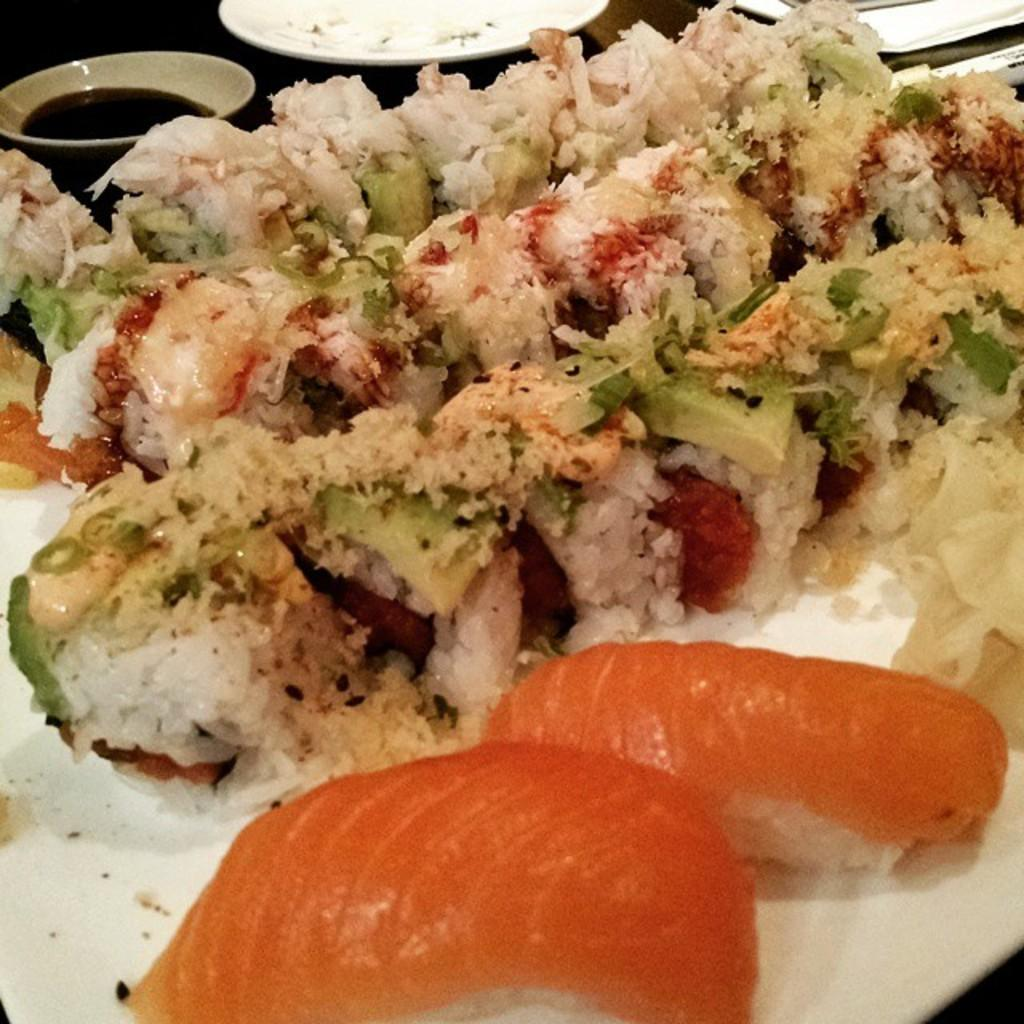What is being served on the plate in the image? The facts provided do not specify what is being served on the plate. What type of sauce is in the bowl in the image? The facts provided do not specify the type of sauce in the bowl. How many robins can be seen perched on the plate in the image? There are no robins present in the image. What is the bit size of the items served on the plate in the image? The facts provided do not specify the size of the items served on the plate. 